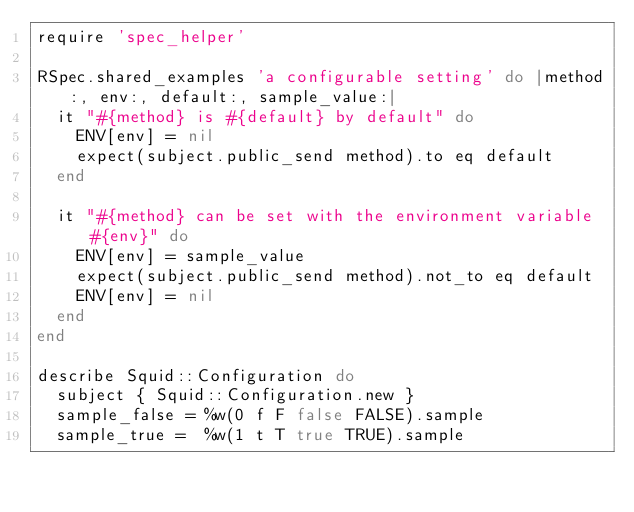<code> <loc_0><loc_0><loc_500><loc_500><_Ruby_>require 'spec_helper'

RSpec.shared_examples 'a configurable setting' do |method:, env:, default:, sample_value:|
  it "#{method} is #{default} by default" do
    ENV[env] = nil
    expect(subject.public_send method).to eq default
  end

  it "#{method} can be set with the environment variable #{env}" do
    ENV[env] = sample_value
    expect(subject.public_send method).not_to eq default
    ENV[env] = nil
  end
end

describe Squid::Configuration do
  subject { Squid::Configuration.new }
  sample_false = %w(0 f F false FALSE).sample
  sample_true =  %w(1 t T true TRUE).sample
</code> 